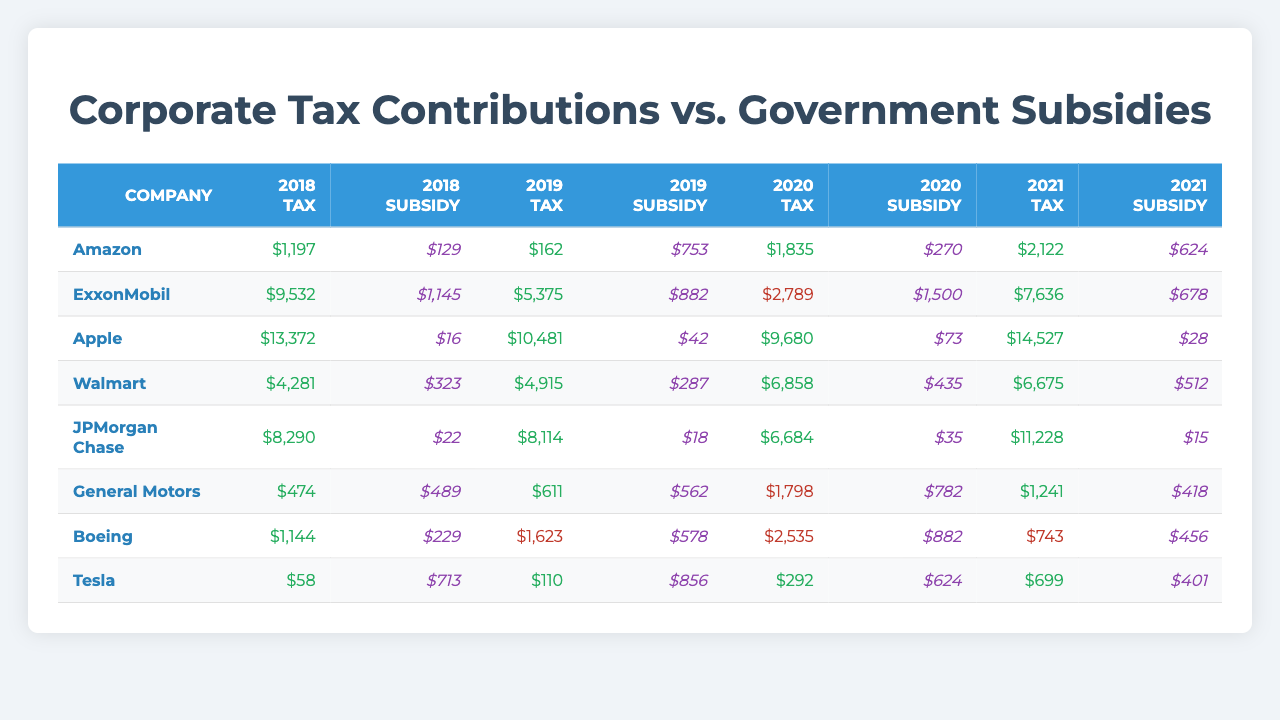What was Amazon's total tax contribution over the years listed? To find Amazon's total tax contribution, we sum the tax contributions for each year: 1197 + 162 + 1835 + 2122 = 4316.
Answer: 4316 In which year did ExxonMobil receive the highest subsidy? By examining the subsidy values for ExxonMobil across the years, we can see that the highest subsidy was 1500 in 2020.
Answer: 2020 What was the average tax contribution for Apple from 2018 to 2021? To calculate the average, we sum Apple’s taxes: 13372 + 10481 + 9680 + 14527 = 48060, and then divide by the number of years (4): 48060 / 4 = 12015.
Answer: 12015 Did Boeing contribute positively to taxes in every year listed? Reviewing Boeing's taxes, we see negative contributions in 2019 and 2020 (−1623 and −2535, respectively), so the answer is no.
Answer: No Which company had the largest tax in 2021, and what was the amount? In 2021, the tax contributions show 14527 for Apple, which is the largest among all companies that year.
Answer: Apple, 14527 What is the total subsidy received by Tesla from 2018 to 2021? To find Tesla's total subsidy, we sum the subsidies: 713 + 856 + 624 + 401 = 2594.
Answer: 2594 Which company had the greatest difference between tax contributions and subsidies in 2020? In 2020, the tax contributions and subsidies show: ExxonMobil's tax −2789 and subsidy 1500 = −2789 - 1500 = −4289; this is the largest negative difference.
Answer: ExxonMobil Was General Motors more reliant on subsidies than taxes in 2020? General Motors had a tax contribution of −1798 and received 782 in subsidies, indicating a heavier reliance on subsidies that year.
Answer: Yes What was the overall trend in tax contributions for Walmart over the years? Walmart's tax contributions were: 4281 (2018), 4915 (2019), 6858 (2020), and 6675 (2021). The trend started high, peaked in 2020, then decreased slightly in 2021.
Answer: Increasing, then decreasing slightly Which company consistently received more subsidies than they contributed in taxes over the years? Both ExxonMobil (in 2020) and Boeing (in all years) showed instances of subsidies exceeding their tax contributions, but Boeing did so consistently.
Answer: Boeing 